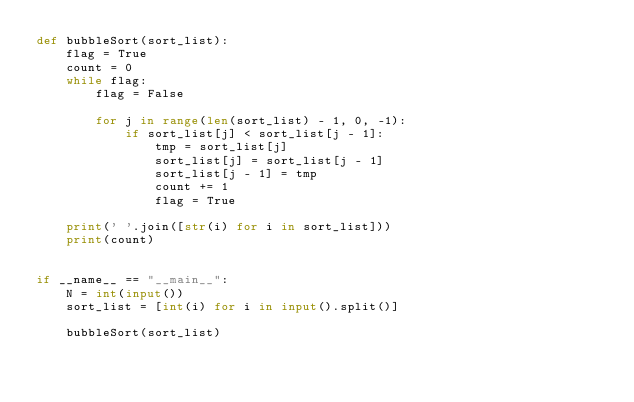Convert code to text. <code><loc_0><loc_0><loc_500><loc_500><_Python_>def bubbleSort(sort_list):
    flag = True
    count = 0
    while flag:
        flag = False

        for j in range(len(sort_list) - 1, 0, -1):
            if sort_list[j] < sort_list[j - 1]:
                tmp = sort_list[j]
                sort_list[j] = sort_list[j - 1]
                sort_list[j - 1] = tmp
                count += 1
                flag = True

    print(' '.join([str(i) for i in sort_list]))
    print(count)


if __name__ == "__main__":
    N = int(input())
    sort_list = [int(i) for i in input().split()]

    bubbleSort(sort_list)

</code> 